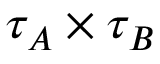<formula> <loc_0><loc_0><loc_500><loc_500>{ \tau _ { A } } \times { \tau _ { B } }</formula> 